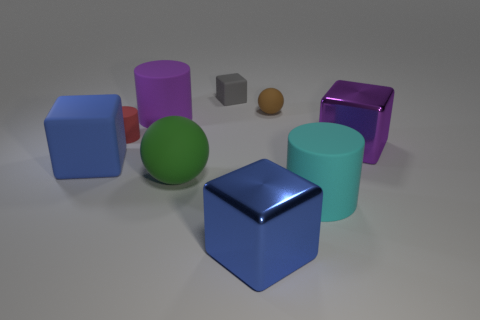How many objects are there and can you describe their shapes? There are seven distinct objects, including four cubes, two cylinders, and one sphere. Each object has a unique color, and their surfaces range from highly reflective to matte. 